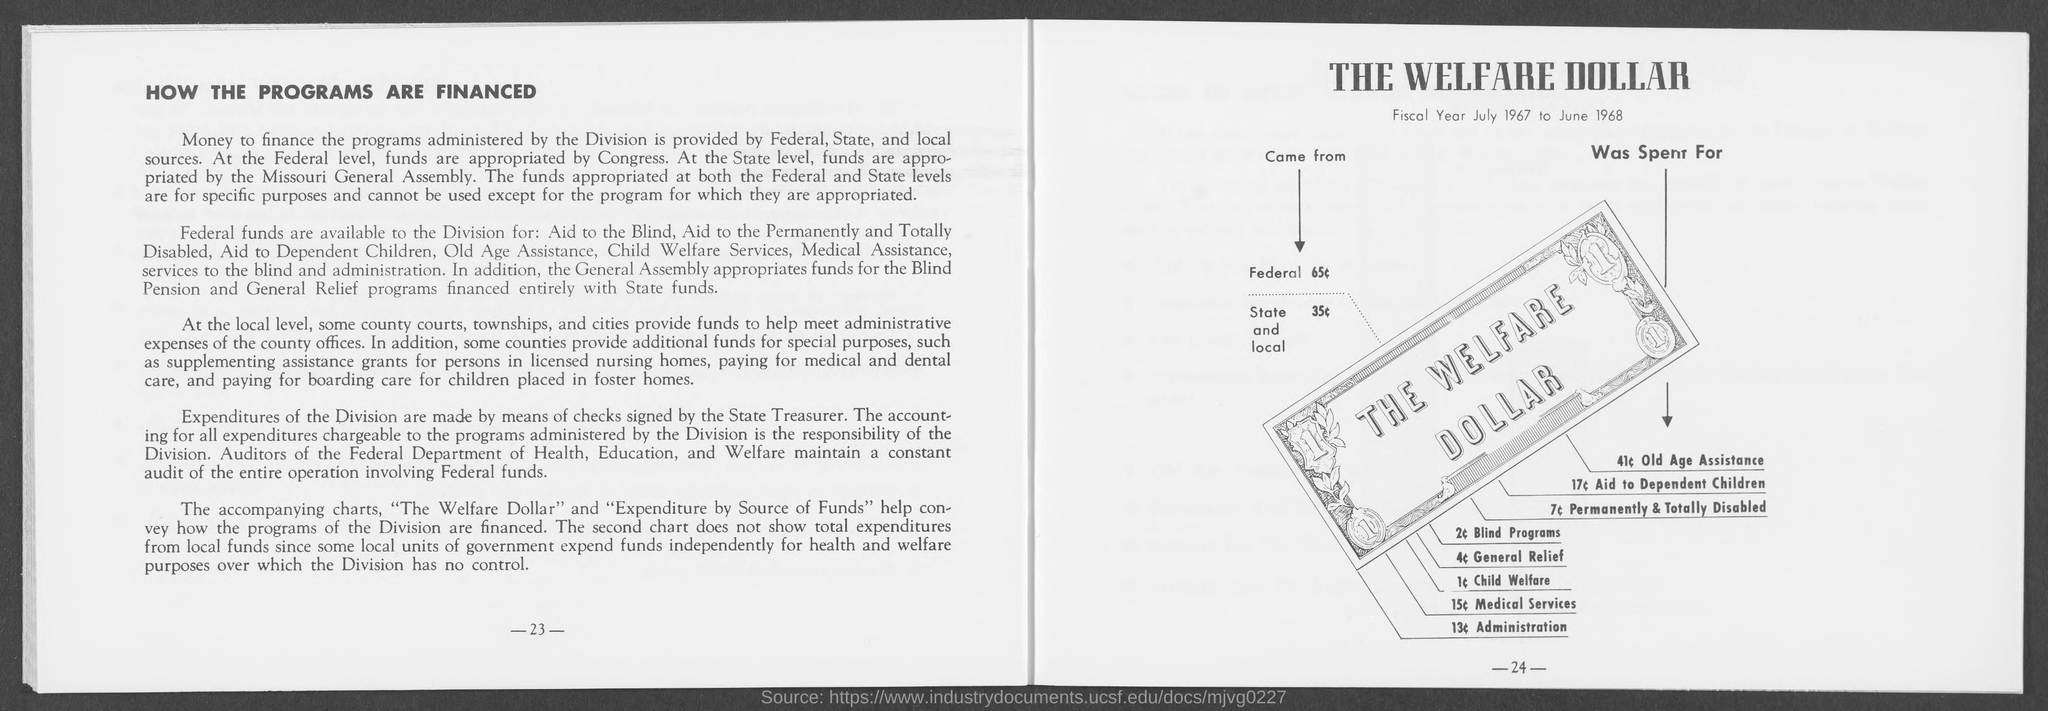List a handful of essential elements in this visual. The number located at the bottom-right side of the page is -24-. The number at the bottom left side of the page is 23. 